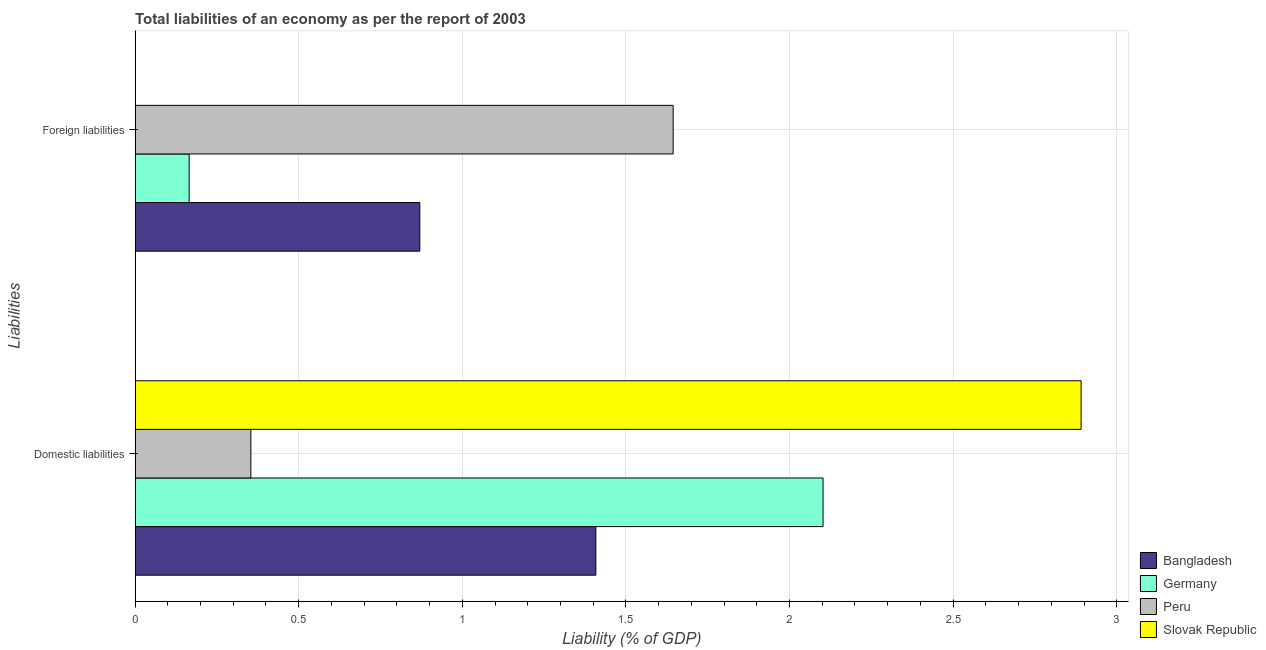How many groups of bars are there?
Provide a short and direct response. 2. How many bars are there on the 1st tick from the top?
Offer a very short reply. 3. How many bars are there on the 1st tick from the bottom?
Provide a short and direct response. 4. What is the label of the 1st group of bars from the top?
Provide a succinct answer. Foreign liabilities. What is the incurrence of domestic liabilities in Peru?
Your response must be concise. 0.35. Across all countries, what is the maximum incurrence of domestic liabilities?
Ensure brevity in your answer.  2.89. Across all countries, what is the minimum incurrence of foreign liabilities?
Offer a very short reply. 0. In which country was the incurrence of domestic liabilities maximum?
Provide a succinct answer. Slovak Republic. What is the total incurrence of foreign liabilities in the graph?
Keep it short and to the point. 2.68. What is the difference between the incurrence of domestic liabilities in Slovak Republic and that in Peru?
Provide a succinct answer. 2.54. What is the difference between the incurrence of foreign liabilities in Peru and the incurrence of domestic liabilities in Germany?
Your answer should be very brief. -0.46. What is the average incurrence of domestic liabilities per country?
Keep it short and to the point. 1.69. What is the difference between the incurrence of foreign liabilities and incurrence of domestic liabilities in Peru?
Your answer should be compact. 1.29. In how many countries, is the incurrence of domestic liabilities greater than 2.4 %?
Offer a very short reply. 1. What is the ratio of the incurrence of foreign liabilities in Peru to that in Germany?
Keep it short and to the point. 9.95. How many bars are there?
Make the answer very short. 7. Are all the bars in the graph horizontal?
Keep it short and to the point. Yes. How many countries are there in the graph?
Your answer should be compact. 4. Are the values on the major ticks of X-axis written in scientific E-notation?
Provide a short and direct response. No. Does the graph contain grids?
Your answer should be very brief. Yes. Where does the legend appear in the graph?
Provide a succinct answer. Bottom right. What is the title of the graph?
Offer a terse response. Total liabilities of an economy as per the report of 2003. Does "Benin" appear as one of the legend labels in the graph?
Ensure brevity in your answer.  No. What is the label or title of the X-axis?
Offer a terse response. Liability (% of GDP). What is the label or title of the Y-axis?
Give a very brief answer. Liabilities. What is the Liability (% of GDP) of Bangladesh in Domestic liabilities?
Keep it short and to the point. 1.41. What is the Liability (% of GDP) of Germany in Domestic liabilities?
Make the answer very short. 2.1. What is the Liability (% of GDP) in Peru in Domestic liabilities?
Provide a short and direct response. 0.35. What is the Liability (% of GDP) in Slovak Republic in Domestic liabilities?
Provide a short and direct response. 2.89. What is the Liability (% of GDP) of Bangladesh in Foreign liabilities?
Offer a terse response. 0.87. What is the Liability (% of GDP) in Germany in Foreign liabilities?
Provide a short and direct response. 0.17. What is the Liability (% of GDP) of Peru in Foreign liabilities?
Make the answer very short. 1.64. Across all Liabilities, what is the maximum Liability (% of GDP) in Bangladesh?
Provide a succinct answer. 1.41. Across all Liabilities, what is the maximum Liability (% of GDP) of Germany?
Offer a terse response. 2.1. Across all Liabilities, what is the maximum Liability (% of GDP) of Peru?
Ensure brevity in your answer.  1.64. Across all Liabilities, what is the maximum Liability (% of GDP) of Slovak Republic?
Provide a short and direct response. 2.89. Across all Liabilities, what is the minimum Liability (% of GDP) in Bangladesh?
Your answer should be compact. 0.87. Across all Liabilities, what is the minimum Liability (% of GDP) of Germany?
Offer a terse response. 0.17. Across all Liabilities, what is the minimum Liability (% of GDP) of Peru?
Offer a terse response. 0.35. Across all Liabilities, what is the minimum Liability (% of GDP) of Slovak Republic?
Keep it short and to the point. 0. What is the total Liability (% of GDP) of Bangladesh in the graph?
Provide a succinct answer. 2.28. What is the total Liability (% of GDP) of Germany in the graph?
Your answer should be compact. 2.27. What is the total Liability (% of GDP) in Peru in the graph?
Ensure brevity in your answer.  2. What is the total Liability (% of GDP) in Slovak Republic in the graph?
Your response must be concise. 2.89. What is the difference between the Liability (% of GDP) in Bangladesh in Domestic liabilities and that in Foreign liabilities?
Make the answer very short. 0.54. What is the difference between the Liability (% of GDP) in Germany in Domestic liabilities and that in Foreign liabilities?
Your response must be concise. 1.94. What is the difference between the Liability (% of GDP) in Peru in Domestic liabilities and that in Foreign liabilities?
Provide a succinct answer. -1.29. What is the difference between the Liability (% of GDP) in Bangladesh in Domestic liabilities and the Liability (% of GDP) in Germany in Foreign liabilities?
Keep it short and to the point. 1.24. What is the difference between the Liability (% of GDP) in Bangladesh in Domestic liabilities and the Liability (% of GDP) in Peru in Foreign liabilities?
Offer a very short reply. -0.24. What is the difference between the Liability (% of GDP) of Germany in Domestic liabilities and the Liability (% of GDP) of Peru in Foreign liabilities?
Offer a terse response. 0.46. What is the average Liability (% of GDP) of Bangladesh per Liabilities?
Your answer should be compact. 1.14. What is the average Liability (% of GDP) of Germany per Liabilities?
Offer a very short reply. 1.13. What is the average Liability (% of GDP) of Peru per Liabilities?
Your response must be concise. 1. What is the average Liability (% of GDP) in Slovak Republic per Liabilities?
Offer a terse response. 1.45. What is the difference between the Liability (% of GDP) in Bangladesh and Liability (% of GDP) in Germany in Domestic liabilities?
Offer a very short reply. -0.69. What is the difference between the Liability (% of GDP) of Bangladesh and Liability (% of GDP) of Peru in Domestic liabilities?
Offer a terse response. 1.05. What is the difference between the Liability (% of GDP) of Bangladesh and Liability (% of GDP) of Slovak Republic in Domestic liabilities?
Offer a very short reply. -1.48. What is the difference between the Liability (% of GDP) in Germany and Liability (% of GDP) in Peru in Domestic liabilities?
Ensure brevity in your answer.  1.75. What is the difference between the Liability (% of GDP) in Germany and Liability (% of GDP) in Slovak Republic in Domestic liabilities?
Your response must be concise. -0.79. What is the difference between the Liability (% of GDP) of Peru and Liability (% of GDP) of Slovak Republic in Domestic liabilities?
Provide a short and direct response. -2.54. What is the difference between the Liability (% of GDP) of Bangladesh and Liability (% of GDP) of Germany in Foreign liabilities?
Your answer should be very brief. 0.7. What is the difference between the Liability (% of GDP) of Bangladesh and Liability (% of GDP) of Peru in Foreign liabilities?
Ensure brevity in your answer.  -0.77. What is the difference between the Liability (% of GDP) of Germany and Liability (% of GDP) of Peru in Foreign liabilities?
Your answer should be very brief. -1.48. What is the ratio of the Liability (% of GDP) of Bangladesh in Domestic liabilities to that in Foreign liabilities?
Provide a succinct answer. 1.62. What is the ratio of the Liability (% of GDP) in Germany in Domestic liabilities to that in Foreign liabilities?
Offer a terse response. 12.72. What is the ratio of the Liability (% of GDP) of Peru in Domestic liabilities to that in Foreign liabilities?
Your answer should be very brief. 0.22. What is the difference between the highest and the second highest Liability (% of GDP) of Bangladesh?
Your answer should be very brief. 0.54. What is the difference between the highest and the second highest Liability (% of GDP) of Germany?
Your answer should be compact. 1.94. What is the difference between the highest and the second highest Liability (% of GDP) of Peru?
Ensure brevity in your answer.  1.29. What is the difference between the highest and the lowest Liability (% of GDP) in Bangladesh?
Make the answer very short. 0.54. What is the difference between the highest and the lowest Liability (% of GDP) of Germany?
Your response must be concise. 1.94. What is the difference between the highest and the lowest Liability (% of GDP) in Peru?
Offer a very short reply. 1.29. What is the difference between the highest and the lowest Liability (% of GDP) of Slovak Republic?
Ensure brevity in your answer.  2.89. 